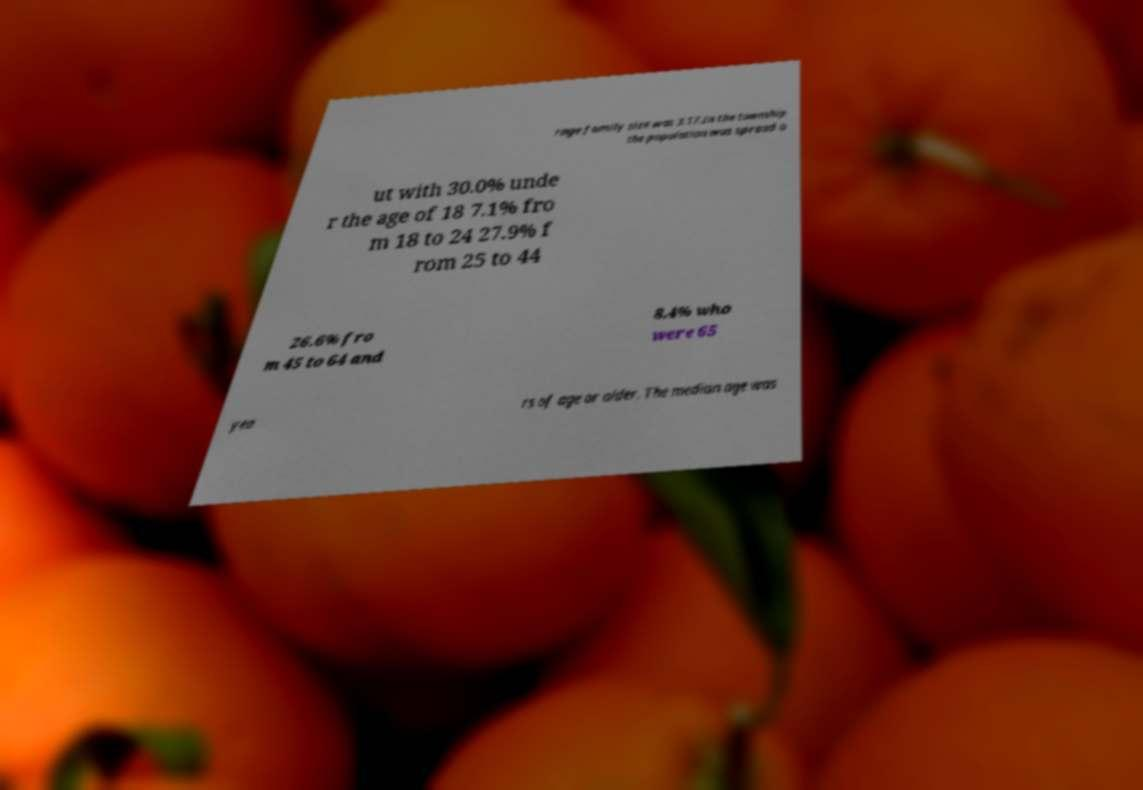There's text embedded in this image that I need extracted. Can you transcribe it verbatim? rage family size was 3.17.In the township the population was spread o ut with 30.0% unde r the age of 18 7.1% fro m 18 to 24 27.9% f rom 25 to 44 26.6% fro m 45 to 64 and 8.4% who were 65 yea rs of age or older. The median age was 